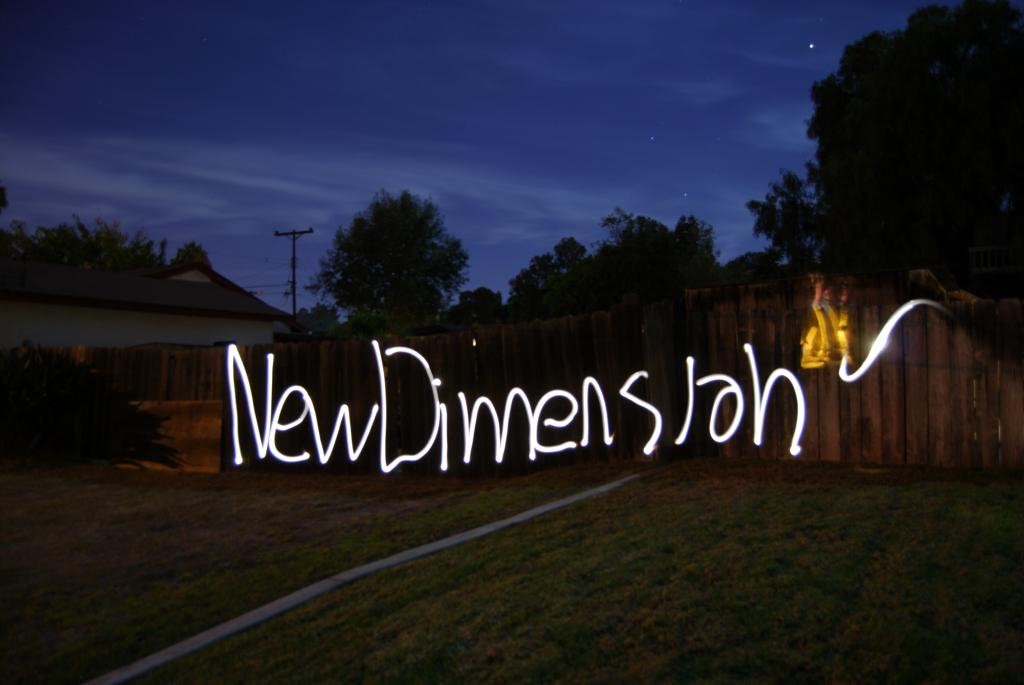What type of vegetation can be seen in the image? There are trees in the image. What type of barrier is present in the image? There is a wooden fence in the image. What type of ground cover is visible in the image? There is grass in the image. What type of building is present in the image? There is a house in the image. What type of infrastructure is present in the image? There is an electric pole with cables in the image. What celestial objects can be seen in the image? There are stars visible in the sky. How many chairs are visible in the image? There are no chairs present in the image. What type of facial expression can be seen on the house in the image? The house does not have a face or facial expression; it is a building. 